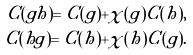Convert formula to latex. <formula><loc_0><loc_0><loc_500><loc_500>C ( g h ) = C ( g ) + { \chi } ( g ) C ( h ) , \\ C ( h g ) = C ( h ) + { \chi } ( h ) C ( g ) .</formula> 